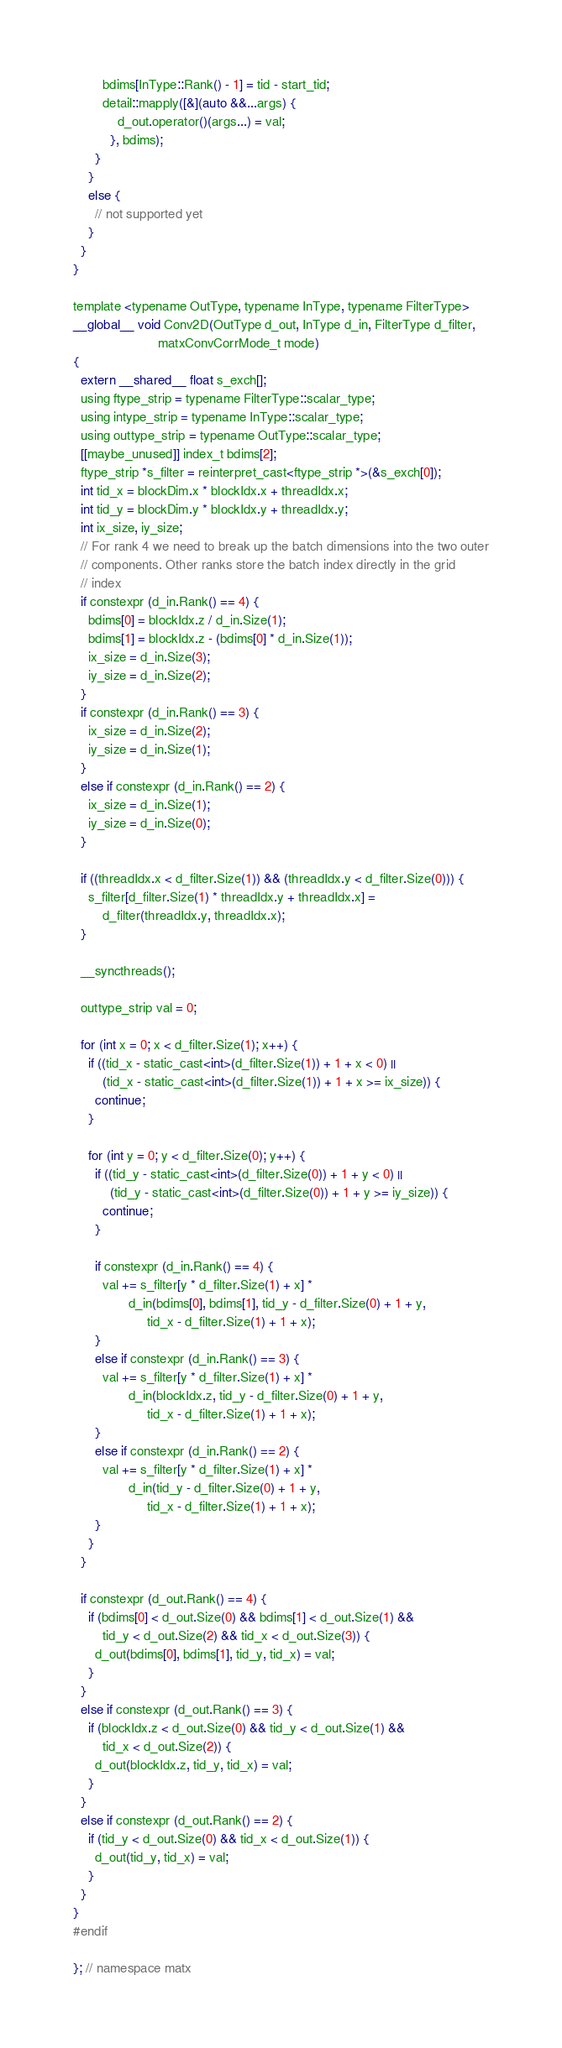Convert code to text. <code><loc_0><loc_0><loc_500><loc_500><_Cuda_>        bdims[InType::Rank() - 1] = tid - start_tid; 
        detail::mapply([&](auto &&...args) {
            d_out.operator()(args...) = val;
          }, bdims);
      }
    }
    else {
      // not supported yet
    }
  }
}

template <typename OutType, typename InType, typename FilterType>
__global__ void Conv2D(OutType d_out, InType d_in, FilterType d_filter,
                       matxConvCorrMode_t mode)
{
  extern __shared__ float s_exch[];
  using ftype_strip = typename FilterType::scalar_type;
  using intype_strip = typename InType::scalar_type;
  using outtype_strip = typename OutType::scalar_type;
  [[maybe_unused]] index_t bdims[2];
  ftype_strip *s_filter = reinterpret_cast<ftype_strip *>(&s_exch[0]);
  int tid_x = blockDim.x * blockIdx.x + threadIdx.x;
  int tid_y = blockDim.y * blockIdx.y + threadIdx.y;
  int ix_size, iy_size;
  // For rank 4 we need to break up the batch dimensions into the two outer
  // components. Other ranks store the batch index directly in the grid
  // index
  if constexpr (d_in.Rank() == 4) {
    bdims[0] = blockIdx.z / d_in.Size(1);
    bdims[1] = blockIdx.z - (bdims[0] * d_in.Size(1));
    ix_size = d_in.Size(3);
    iy_size = d_in.Size(2);
  }
  if constexpr (d_in.Rank() == 3) {
    ix_size = d_in.Size(2);
    iy_size = d_in.Size(1);
  }
  else if constexpr (d_in.Rank() == 2) {
    ix_size = d_in.Size(1);
    iy_size = d_in.Size(0);
  }

  if ((threadIdx.x < d_filter.Size(1)) && (threadIdx.y < d_filter.Size(0))) {
    s_filter[d_filter.Size(1) * threadIdx.y + threadIdx.x] =
        d_filter(threadIdx.y, threadIdx.x);
  }

  __syncthreads();

  outtype_strip val = 0;

  for (int x = 0; x < d_filter.Size(1); x++) {
    if ((tid_x - static_cast<int>(d_filter.Size(1)) + 1 + x < 0) ||
        (tid_x - static_cast<int>(d_filter.Size(1)) + 1 + x >= ix_size)) {
      continue;
    }

    for (int y = 0; y < d_filter.Size(0); y++) {
      if ((tid_y - static_cast<int>(d_filter.Size(0)) + 1 + y < 0) ||
          (tid_y - static_cast<int>(d_filter.Size(0)) + 1 + y >= iy_size)) {
        continue;
      }

      if constexpr (d_in.Rank() == 4) {
        val += s_filter[y * d_filter.Size(1) + x] *
               d_in(bdims[0], bdims[1], tid_y - d_filter.Size(0) + 1 + y,
                    tid_x - d_filter.Size(1) + 1 + x);
      }
      else if constexpr (d_in.Rank() == 3) {
        val += s_filter[y * d_filter.Size(1) + x] *
               d_in(blockIdx.z, tid_y - d_filter.Size(0) + 1 + y,
                    tid_x - d_filter.Size(1) + 1 + x);
      }
      else if constexpr (d_in.Rank() == 2) {
        val += s_filter[y * d_filter.Size(1) + x] *
               d_in(tid_y - d_filter.Size(0) + 1 + y,
                    tid_x - d_filter.Size(1) + 1 + x);
      }
    }
  }

  if constexpr (d_out.Rank() == 4) {
    if (bdims[0] < d_out.Size(0) && bdims[1] < d_out.Size(1) &&
        tid_y < d_out.Size(2) && tid_x < d_out.Size(3)) {
      d_out(bdims[0], bdims[1], tid_y, tid_x) = val;
    }
  }
  else if constexpr (d_out.Rank() == 3) {
    if (blockIdx.z < d_out.Size(0) && tid_y < d_out.Size(1) &&
        tid_x < d_out.Size(2)) {
      d_out(blockIdx.z, tid_y, tid_x) = val;
    }
  }
  else if constexpr (d_out.Rank() == 2) {
    if (tid_y < d_out.Size(0) && tid_x < d_out.Size(1)) {
      d_out(tid_y, tid_x) = val;
    }
  }
}
#endif

}; // namespace matx
</code> 